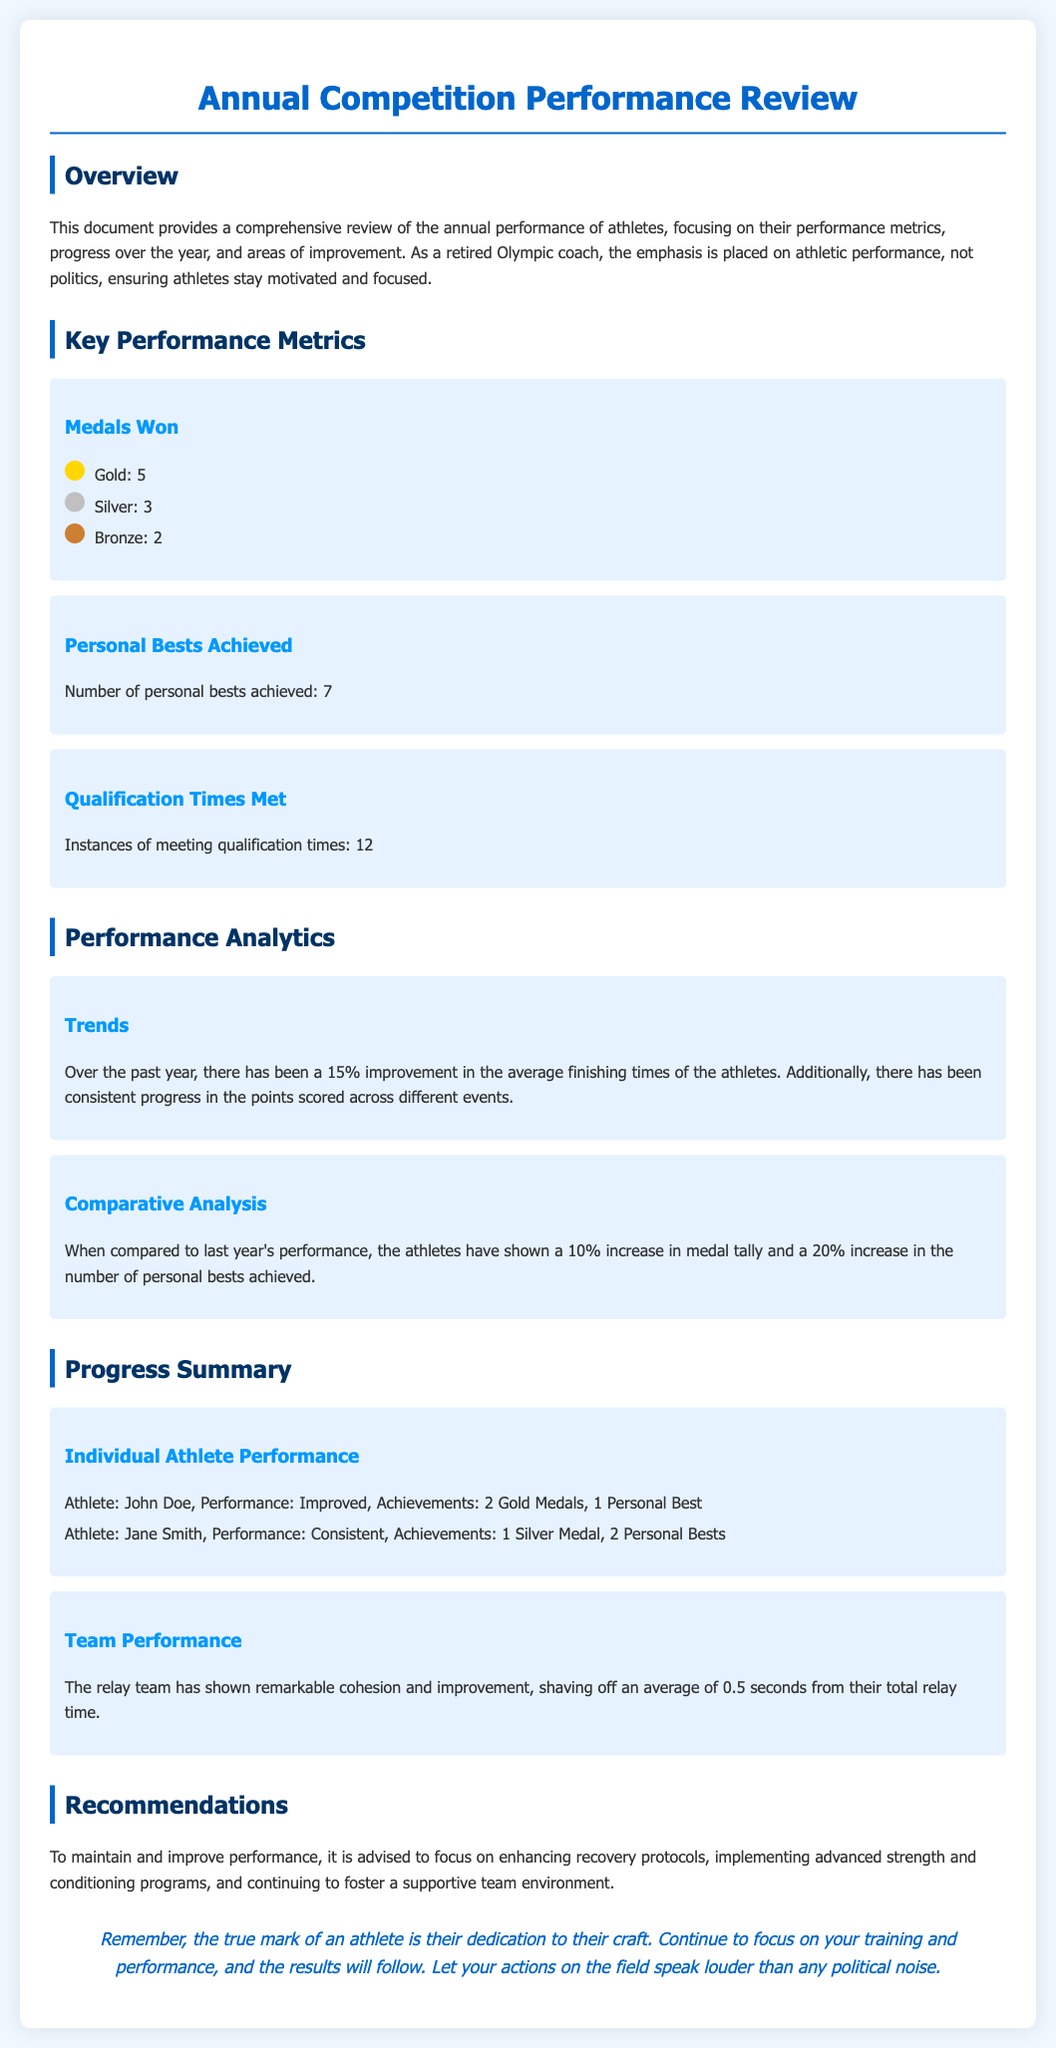What is the total number of gold medals won? The total number of gold medals is stated in the "Medals Won" section as 5.
Answer: 5 How many personal bests were achieved? The document mentions that the athletes achieved 7 personal bests in total.
Answer: 7 What was the percentage improvement in average finishing times? The overview in the "Performance Analytics" section states there was a 15% improvement.
Answer: 15% Who is the athlete that won 2 gold medals? The individual athlete performance section lists John Doe, who won 2 gold medals.
Answer: John Doe What is the average time improvement for the relay team? The document states that the relay team improved by an average of 0.5 seconds.
Answer: 0.5 seconds By what percentage did the medal tally increase compared to last year? The comparative analysis indicates a 10% increase in the medal tally.
Answer: 10% What is one area of focus in the recommendations? The recommendations suggest enhancing recovery protocols as a focus area.
Answer: Recovery protocols How many silver medals were awarded? The "Medals Won" section indicates that there were 3 silver medals awarded.
Answer: 3 What type of document is this? The title at the top of the document clarifies it as an "Annual Competition Performance Review."
Answer: Annual Competition Performance Review 